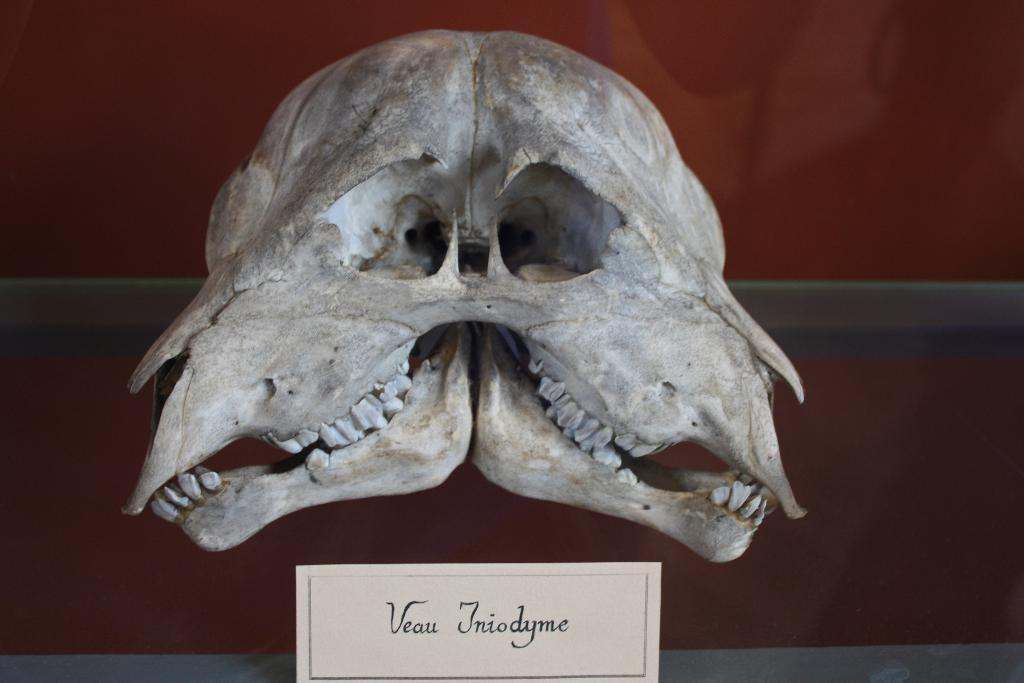What is the main subject of the picture? The main subject of the picture is a skull. Is there any text present in the image? Yes, there is a paper with text at the bottom of the picture. What type of birth is being celebrated in the image? There is no indication of a birth celebration in the image, as it features a skull and a paper with text. What fictional character is being discussed in the image? There is no indication of a discussion about a fictional character in the image, as it features a skull and a paper with text. 